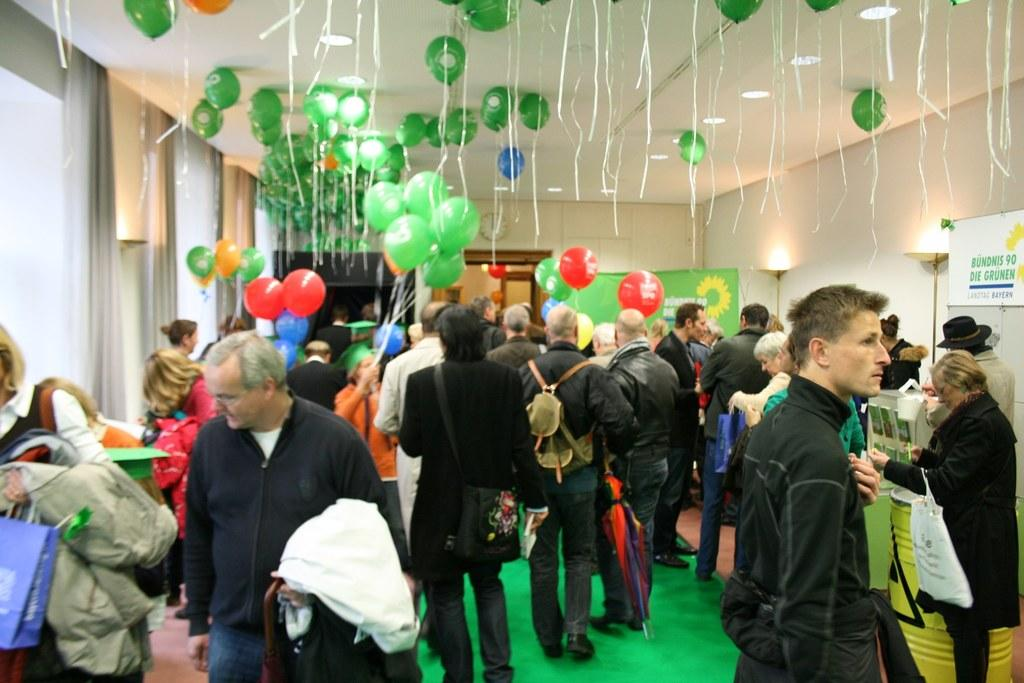How many people are in the group that is visible in the image? There is a group of people in the image, but the exact number is not specified. What are some people holding in the image? Some people are holding bags, while others are holding unspecified objects. What decorative items can be seen in the image? There are colorful balloons, banners, and boards visible in the image. What time-related object is present in the image? A clock is present in the image. What type of lighting is visible in the image? Lights are visible in the image. What type of structure is present in the image? There is a wall in the image. Where is the desk located in the image? There is no desk present in the image. Can you describe the monkey's interaction with the page in the image? There is no monkey or page present in the image. 